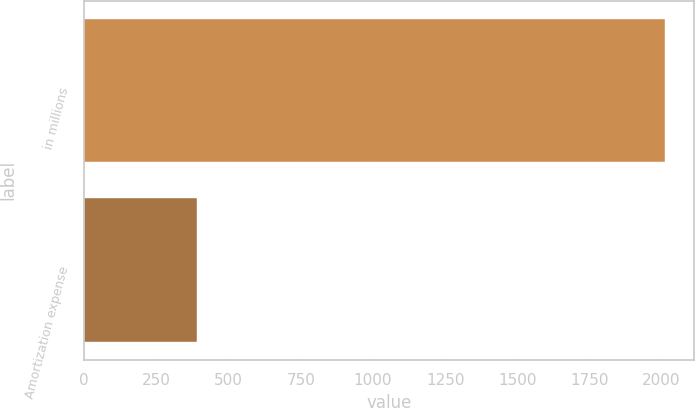Convert chart to OTSL. <chart><loc_0><loc_0><loc_500><loc_500><bar_chart><fcel>in millions<fcel>Amortization expense<nl><fcel>2011<fcel>389<nl></chart> 